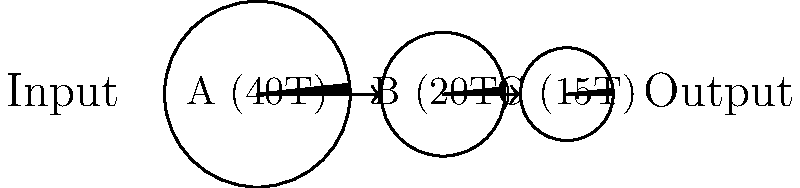Design a gear train using the schematic provided. Gear A has 40 teeth and is the input gear. Gear B has 20 teeth, and Gear C has 15 teeth. Calculate the overall gear ratio and the output speed if the input speed is 1200 RPM. How might this gear train's design relate to the concept of pacing oneself through challenging times? Let's approach this step-by-step:

1. Calculate the gear ratios:
   - Ratio A to B: $\frac{T_B}{T_A} = \frac{20}{40} = \frac{1}{2}$
   - Ratio B to C: $\frac{T_C}{T_B} = \frac{15}{20} = \frac{3}{4}$

2. Overall gear ratio:
   $\text{Overall Ratio} = \frac{1}{2} \times \frac{3}{4} = \frac{3}{8}$

3. Calculate output speed:
   $\text{Output Speed} = \text{Input Speed} \times \text{Overall Ratio}$
   $\text{Output Speed} = 1200 \text{ RPM} \times \frac{3}{8} = 450 \text{ RPM}$

4. Relating to pacing through challenging times:
   This gear train reduces speed, which can be seen as a metaphor for slowing down and pacing oneself during difficult periods. Just as the gears transform high-speed input to lower-speed output, we can learn to manage our energy and emotions, taking things one step at a time. The intermediate gear (B) represents the support systems or coping mechanisms that help us transition through the process of grief while maintaining our professional responsibilities.
Answer: Overall gear ratio: 3:8; Output speed: 450 RPM 